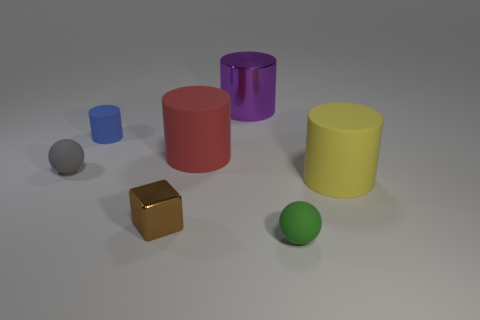What number of spheres are large green matte things or yellow things?
Your answer should be compact. 0. Is there another large red rubber object that has the same shape as the big red thing?
Keep it short and to the point. No. What is the shape of the tiny green thing?
Your response must be concise. Sphere. How many things are gray balls or tiny purple blocks?
Keep it short and to the point. 1. Is the size of the rubber ball behind the small cube the same as the thing in front of the shiny block?
Your answer should be compact. Yes. What number of other things are made of the same material as the brown thing?
Give a very brief answer. 1. Is the number of red rubber cylinders behind the big red matte object greater than the number of big red cylinders that are in front of the small blue rubber cylinder?
Your answer should be very brief. No. What material is the sphere that is left of the tiny brown block?
Offer a terse response. Rubber. Do the tiny metal object and the blue rubber thing have the same shape?
Offer a very short reply. No. Is there any other thing of the same color as the cube?
Your response must be concise. No. 